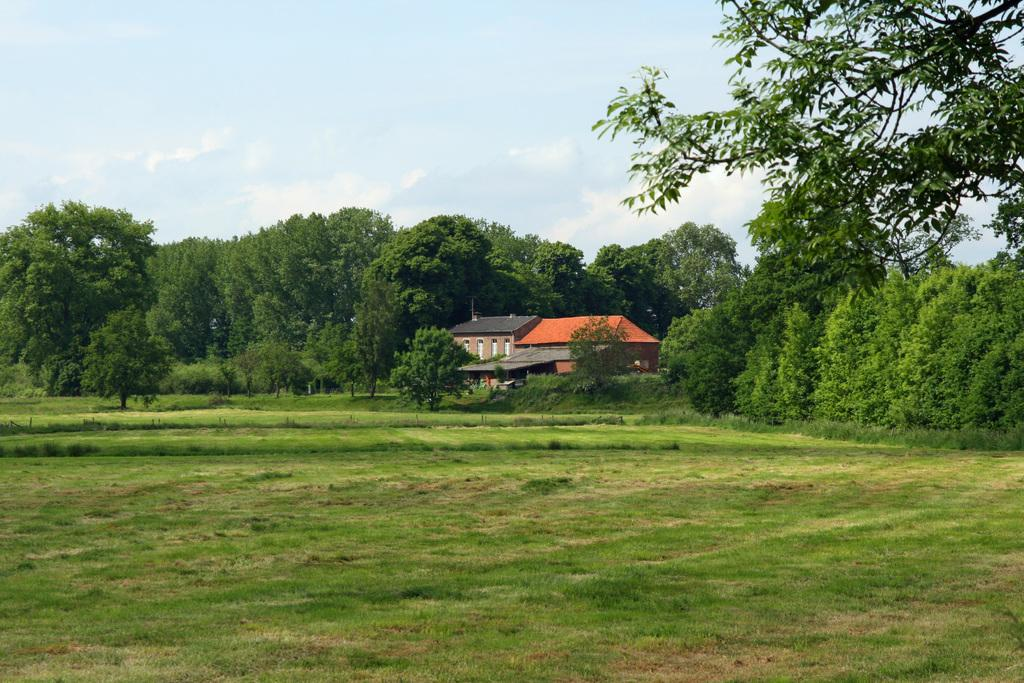What type of vegetation is at the bottom of the image? There is grass at the bottom of the image. What can be seen in the background of the image? There are trees and a house in the background of the image. What is visible at the top of the image? The sky is visible at the top of the image. What type of marble is used for the vest in the image? There is no mention of a vest or marble in the image; it features grass, trees, a house, and the sky. 